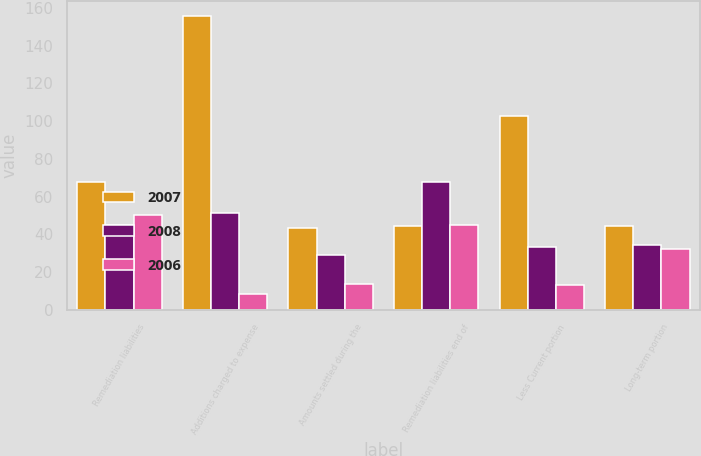Convert chart. <chart><loc_0><loc_0><loc_500><loc_500><stacked_bar_chart><ecel><fcel>Remediation liabilities<fcel>Additions charged to expense<fcel>Amounts settled during the<fcel>Remediation liabilities end of<fcel>Less Current portion<fcel>Long-term portion<nl><fcel>2007<fcel>67.5<fcel>155.9<fcel>43.3<fcel>44.2<fcel>102.8<fcel>44.2<nl><fcel>2008<fcel>45.1<fcel>51.4<fcel>29<fcel>67.5<fcel>33.4<fcel>34.1<nl><fcel>2006<fcel>50.3<fcel>8.5<fcel>13.7<fcel>45.1<fcel>13<fcel>32.1<nl></chart> 